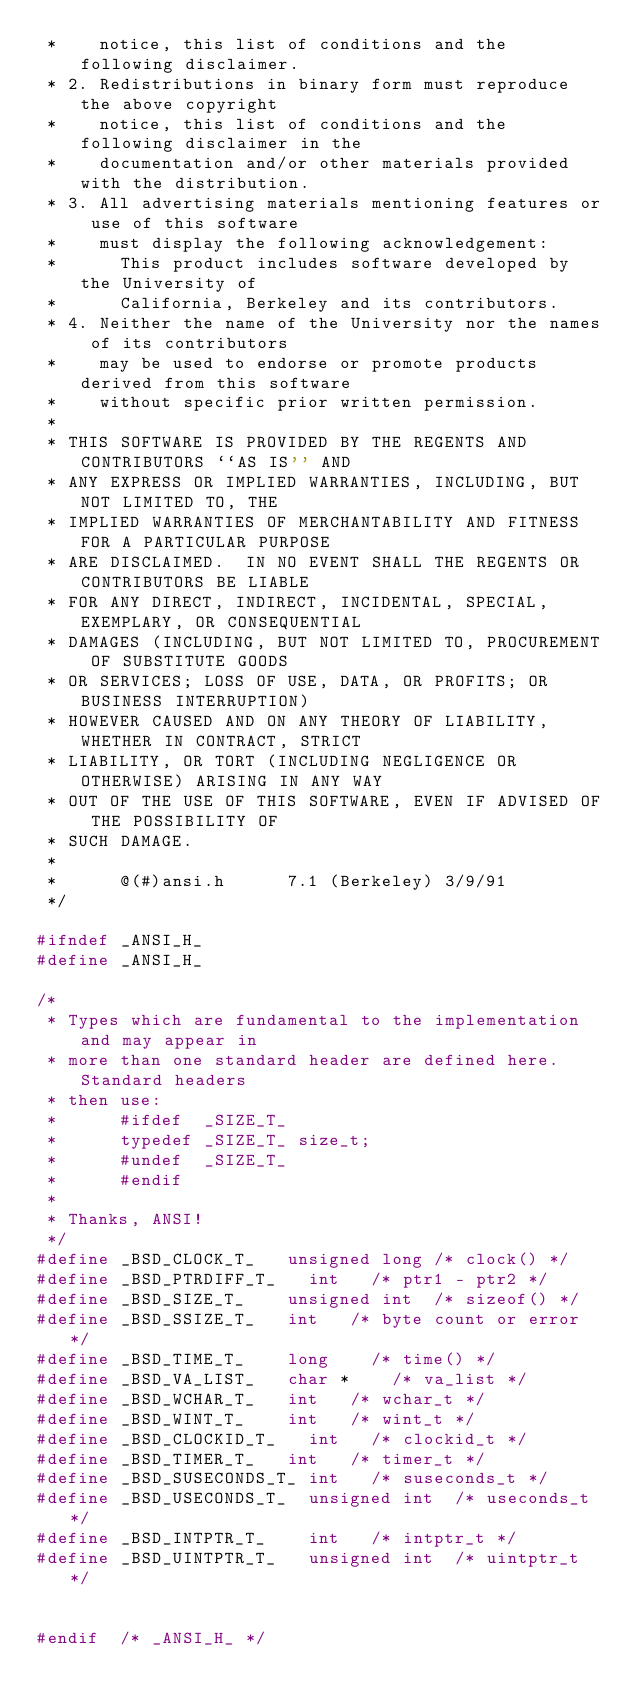<code> <loc_0><loc_0><loc_500><loc_500><_C_> *    notice, this list of conditions and the following disclaimer.
 * 2. Redistributions in binary form must reproduce the above copyright
 *    notice, this list of conditions and the following disclaimer in the
 *    documentation and/or other materials provided with the distribution.
 * 3. All advertising materials mentioning features or use of this software
 *    must display the following acknowledgement:
 *      This product includes software developed by the University of
 *      California, Berkeley and its contributors.
 * 4. Neither the name of the University nor the names of its contributors
 *    may be used to endorse or promote products derived from this software
 *    without specific prior written permission.
 *
 * THIS SOFTWARE IS PROVIDED BY THE REGENTS AND CONTRIBUTORS ``AS IS'' AND
 * ANY EXPRESS OR IMPLIED WARRANTIES, INCLUDING, BUT NOT LIMITED TO, THE
 * IMPLIED WARRANTIES OF MERCHANTABILITY AND FITNESS FOR A PARTICULAR PURPOSE
 * ARE DISCLAIMED.  IN NO EVENT SHALL THE REGENTS OR CONTRIBUTORS BE LIABLE
 * FOR ANY DIRECT, INDIRECT, INCIDENTAL, SPECIAL, EXEMPLARY, OR CONSEQUENTIAL
 * DAMAGES (INCLUDING, BUT NOT LIMITED TO, PROCUREMENT OF SUBSTITUTE GOODS
 * OR SERVICES; LOSS OF USE, DATA, OR PROFITS; OR BUSINESS INTERRUPTION)
 * HOWEVER CAUSED AND ON ANY THEORY OF LIABILITY, WHETHER IN CONTRACT, STRICT
 * LIABILITY, OR TORT (INCLUDING NEGLIGENCE OR OTHERWISE) ARISING IN ANY WAY
 * OUT OF THE USE OF THIS SOFTWARE, EVEN IF ADVISED OF THE POSSIBILITY OF
 * SUCH DAMAGE.
 *
 *      @(#)ansi.h      7.1 (Berkeley) 3/9/91
 */

#ifndef _ANSI_H_
#define _ANSI_H_

/*
 * Types which are fundamental to the implementation and may appear in
 * more than one standard header are defined here.  Standard headers
 * then use:
 *      #ifdef  _SIZE_T_
 *      typedef _SIZE_T_ size_t;
 *      #undef  _SIZE_T_
 *      #endif
 *
 * Thanks, ANSI!
 */
#define	_BSD_CLOCK_T_		unsigned long	/* clock() */
#define	_BSD_PTRDIFF_T_		int		/* ptr1 - ptr2 */
#define	_BSD_SIZE_T_		unsigned int	/* sizeof() */
#define	_BSD_SSIZE_T_		int		/* byte count or error */
#define	_BSD_TIME_T_		long		/* time() */
#define	_BSD_VA_LIST_		char *		/* va_list */
#define	_BSD_WCHAR_T_		int		/* wchar_t */
#define	_BSD_WINT_T_		int		/* wint_t */
#define	_BSD_CLOCKID_T_		int		/* clockid_t */
#define	_BSD_TIMER_T_		int		/* timer_t */
#define	_BSD_SUSECONDS_T_	int		/* suseconds_t */
#define	_BSD_USECONDS_T_	unsigned int	/* useconds_t */
#define	_BSD_INTPTR_T_		int		/* intptr_t */
#define	_BSD_UINTPTR_T_		unsigned int	/* uintptr_t */


#endif  /* _ANSI_H_ */
</code> 